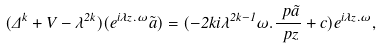<formula> <loc_0><loc_0><loc_500><loc_500>( \Delta ^ { k } + V - \lambda ^ { 2 k } ) ( e ^ { i \lambda z . \omega } \tilde { a } ) = ( - 2 k i \lambda ^ { 2 k - 1 } \omega . \frac { \ p \tilde { a } } { \ p z } + c ) e ^ { i \lambda z . \omega } ,</formula> 